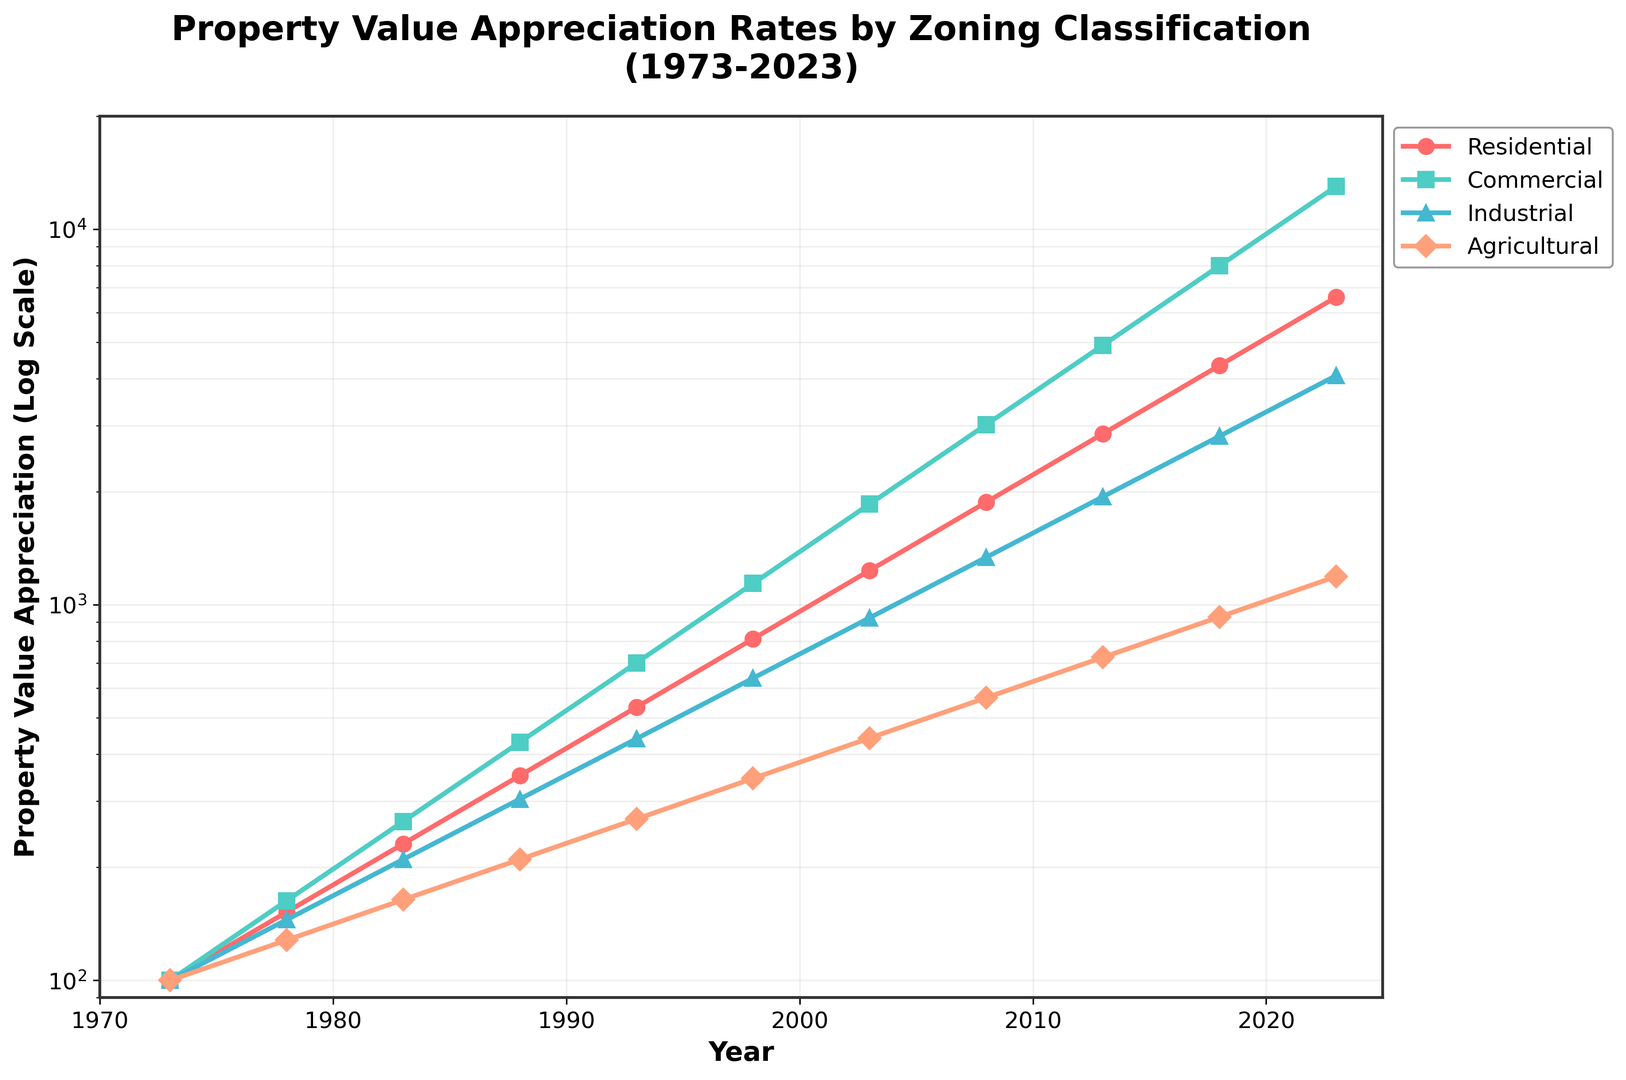How many types of zoning classifications are shown in the plot? The plot shows lines of four different colors with separate markers, each representing a distinct zoning classification.
Answer: 4 Which zoning classification has the highest property value appreciation rate in 2023? By looking at the end points of the lines in 2023, the highest value is represented by the turquoise line labeled "Commercial."
Answer: Commercial What is the total property value appreciation for Residential and Industrial in 1988? To get the total, add the Residential value (351) and the Industrial value (304) for 1988: 351 + 304 = 655.
Answer: 655 Between which two zoning classifications is the difference in appreciation the smallest in 2018? Checking the values in 2018, the values for Residential (4341) and Industrial (2814) have the smallest difference; however, Agricultural (929) and Industrial (2814) are closer together. Calculate: Commercial and Residential: 7999 - 4341 = 3658; Commercial and Industrial: 7999 - 2814 = 5185; Commercial and Agricultural: 7999 - 929 = 7070; Residential and Industrial: 4341 - 2814 = 1527; Residential and Agricultural: 4341 - 929 = 3412; Industrial and Agricultural: 2814 - 929 = 1885. The smallest difference is between Residential and Industrial.
Answer: Residential and Industrial Which zoning classification has shown the most volatile appreciation pattern over the years? The "Commercial" line shows the most dramatic increase, indicating high volatility when compared to other classifications.
Answer: Commercial Compare the growth rates of Industrial and Agricultural properties from 1973 to 2023. Which has grown more and by how much? Growth rates can be found by subtracting the 1973 values from the 2023 values. Industrial: 4080 - 100 = 3980, Agricultural: 1190 - 100 = 1090. Subtract the differences: 3980 - 1090 = 2890. Thus, Industrial properties have grown more by 2890.
Answer: Industrial, 2890 Is there any year where Residential properties appreciated faster than Commercial properties? By comparing the slope of the lines year by year, in 1978, Residential (152) appreciated slower than Commercial (163). For subsequent data points, Commercial consistently shows steeper appreciation. Thus, there is no such year shown in the plot.
Answer: No 